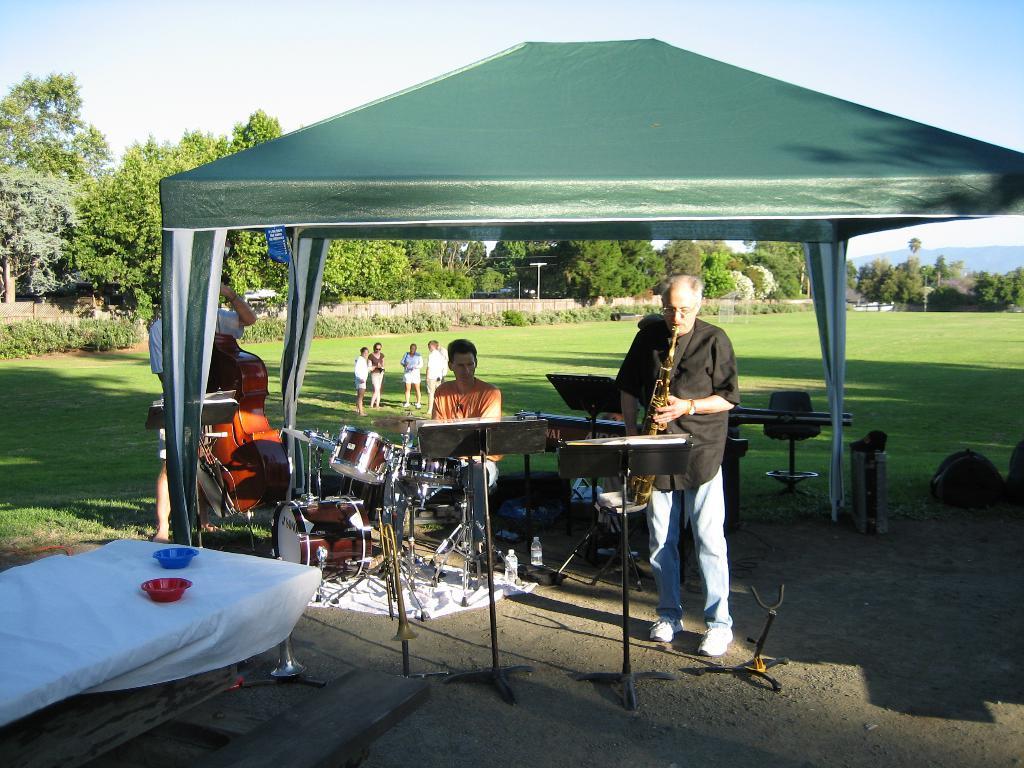Describe this image in one or two sentences. In this picture there are people, among them there is a man standing and playing a musical instrument and we can see stands, musical instruments, bottles, cloth, tent, bowls on the table, grass and objects. In the background of the image we can see trees, plants, poles and sky. 